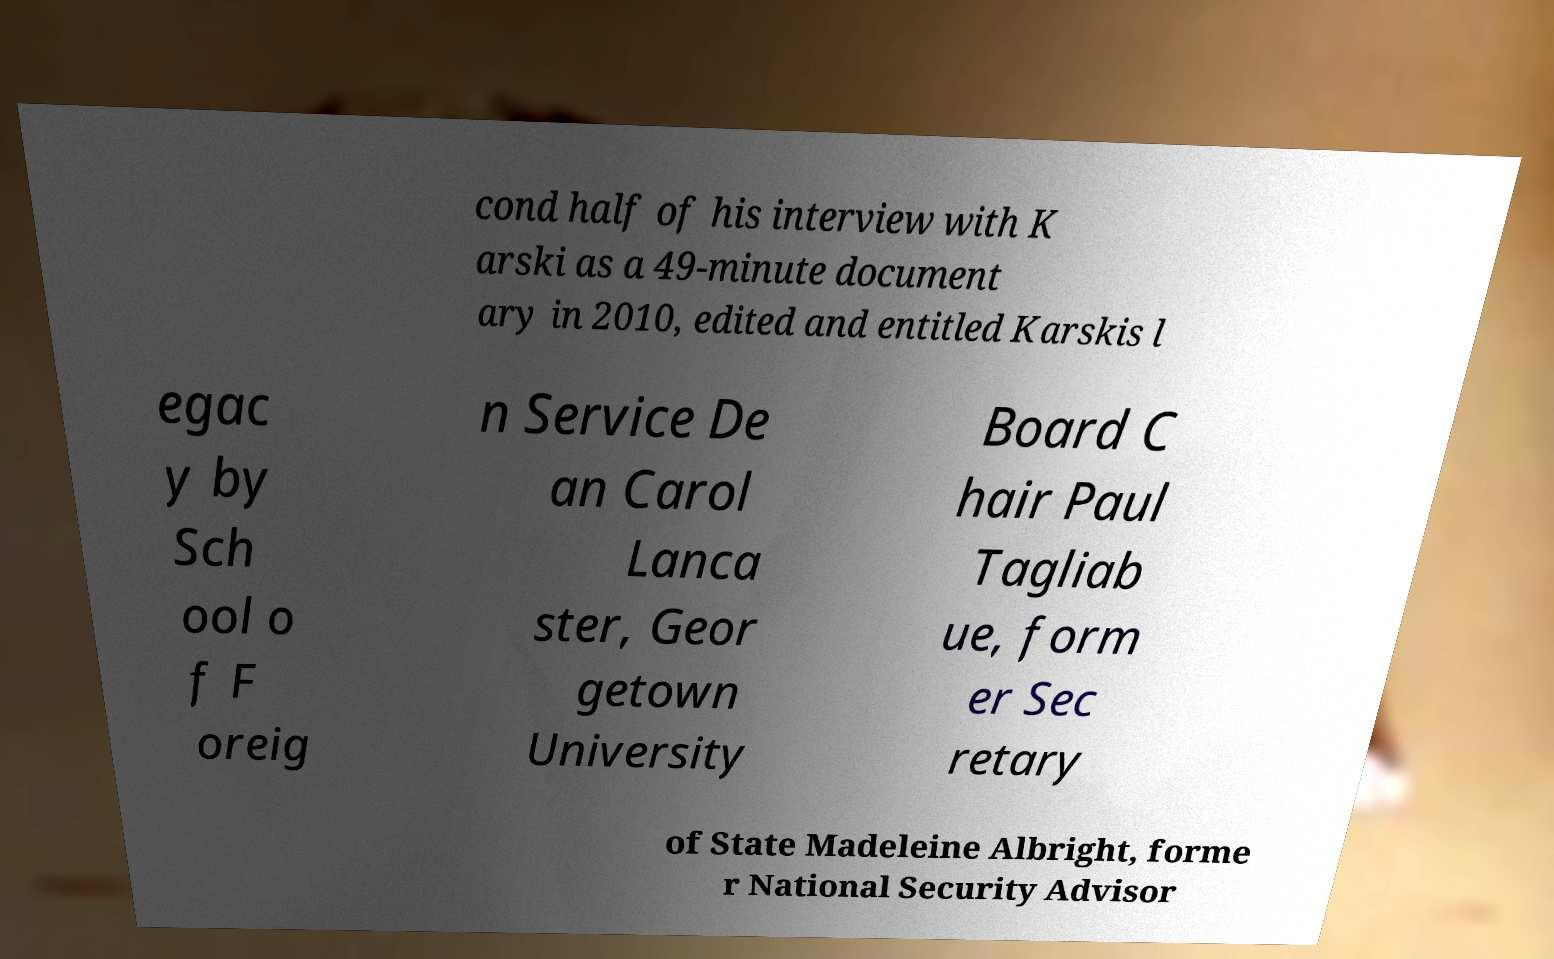I need the written content from this picture converted into text. Can you do that? cond half of his interview with K arski as a 49-minute document ary in 2010, edited and entitled Karskis l egac y by Sch ool o f F oreig n Service De an Carol Lanca ster, Geor getown University Board C hair Paul Tagliab ue, form er Sec retary of State Madeleine Albright, forme r National Security Advisor 